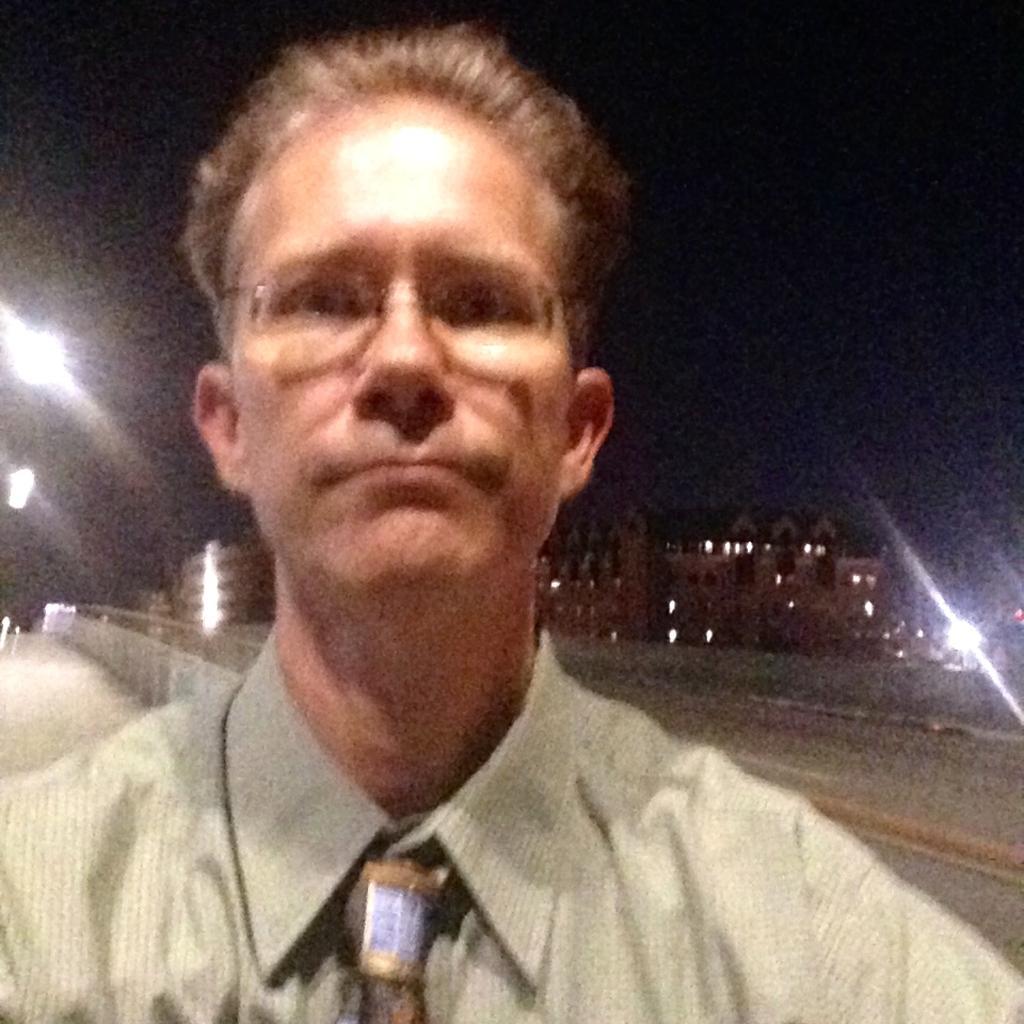Please provide a concise description of this image. In this image we can see a man. On the backside we can see the pathway, some buildings, a fence, lights and the sky. 